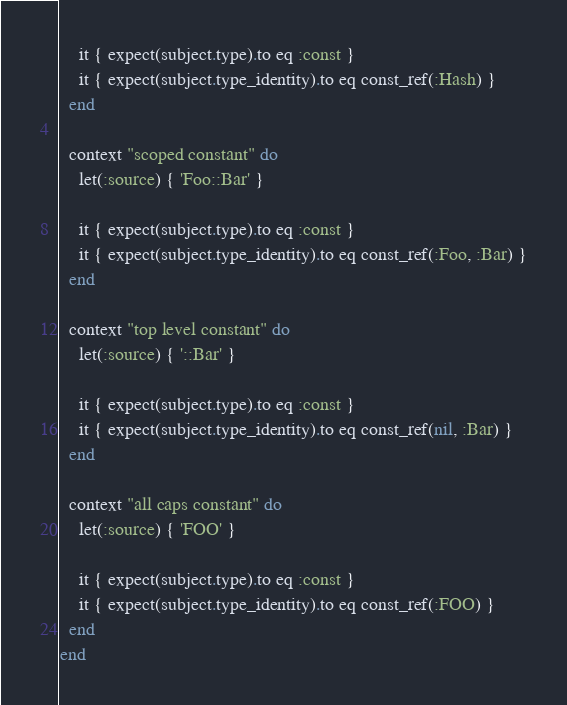<code> <loc_0><loc_0><loc_500><loc_500><_Ruby_>    it { expect(subject.type).to eq :const }
    it { expect(subject.type_identity).to eq const_ref(:Hash) }
  end

  context "scoped constant" do
    let(:source) { 'Foo::Bar' }

    it { expect(subject.type).to eq :const }
    it { expect(subject.type_identity).to eq const_ref(:Foo, :Bar) }
  end

  context "top level constant" do
    let(:source) { '::Bar' }

    it { expect(subject.type).to eq :const }
    it { expect(subject.type_identity).to eq const_ref(nil, :Bar) }
  end

  context "all caps constant" do
    let(:source) { 'FOO' }

    it { expect(subject.type).to eq :const }
    it { expect(subject.type_identity).to eq const_ref(:FOO) }
  end
end
</code> 